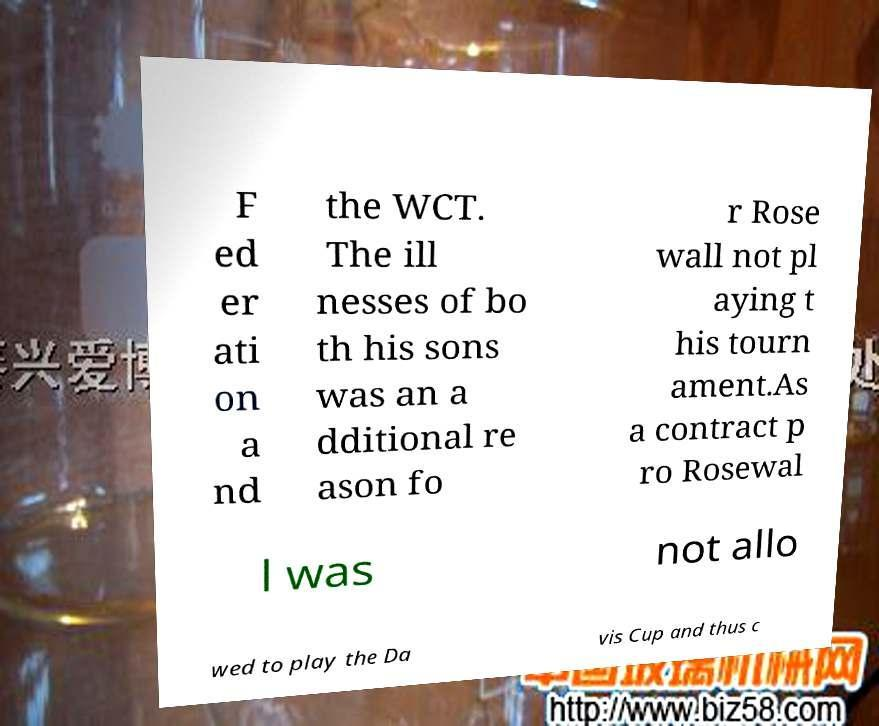Please identify and transcribe the text found in this image. F ed er ati on a nd the WCT. The ill nesses of bo th his sons was an a dditional re ason fo r Rose wall not pl aying t his tourn ament.As a contract p ro Rosewal l was not allo wed to play the Da vis Cup and thus c 